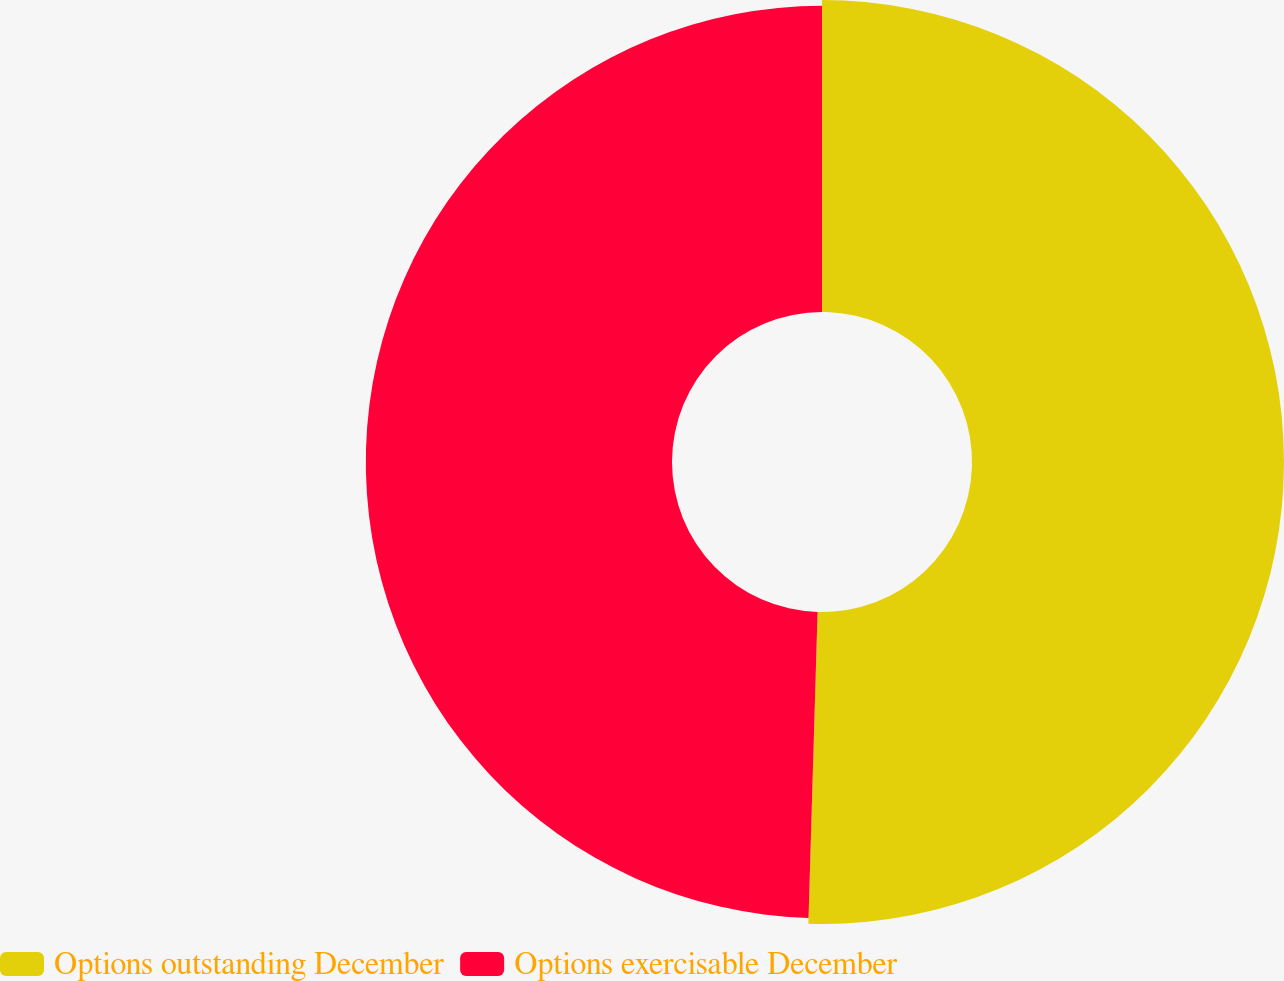Convert chart. <chart><loc_0><loc_0><loc_500><loc_500><pie_chart><fcel>Options outstanding December<fcel>Options exercisable December<nl><fcel>50.47%<fcel>49.53%<nl></chart> 